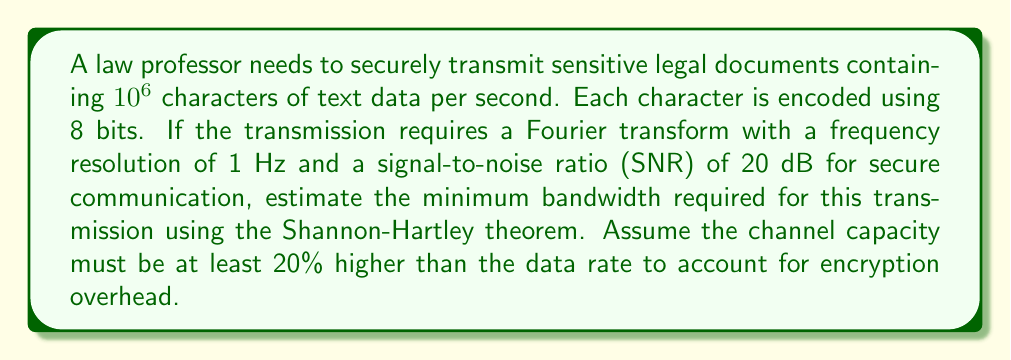Help me with this question. To solve this problem, we'll follow these steps:

1. Calculate the data rate in bits per second:
   $$\text{Data rate} = 10^6 \text{ characters/s} \times 8 \text{ bits/character} = 8 \times 10^6 \text{ bps}$$

2. Account for the 20% encryption overhead:
   $$\text{Required capacity} = 8 \times 10^6 \times 1.2 = 9.6 \times 10^6 \text{ bps}$$

3. Use the Shannon-Hartley theorem to relate channel capacity (C), bandwidth (B), and SNR:
   $$C = B \log_2(1 + \text{SNR})$$

4. Convert the given SNR from dB to linear scale:
   $$\text{SNR}_{\text{linear}} = 10^{\frac{\text{SNR}_{\text{dB}}}{10}} = 10^{\frac{20}{10}} = 100$$

5. Substitute the values into the Shannon-Hartley theorem:
   $$9.6 \times 10^6 = B \log_2(1 + 100)$$

6. Solve for B:
   $$B = \frac{9.6 \times 10^6}{\log_2(101)} \approx 1.44 \times 10^6 \text{ Hz}$$

Therefore, the minimum bandwidth required for secure transmission is approximately 1.44 MHz.
Answer: $$1.44 \text{ MHz}$$ 